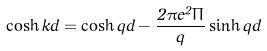<formula> <loc_0><loc_0><loc_500><loc_500>\cosh { k d } = \cosh { q d } - \frac { 2 \pi e ^ { 2 } \Pi } { q } \sinh { q d }</formula> 